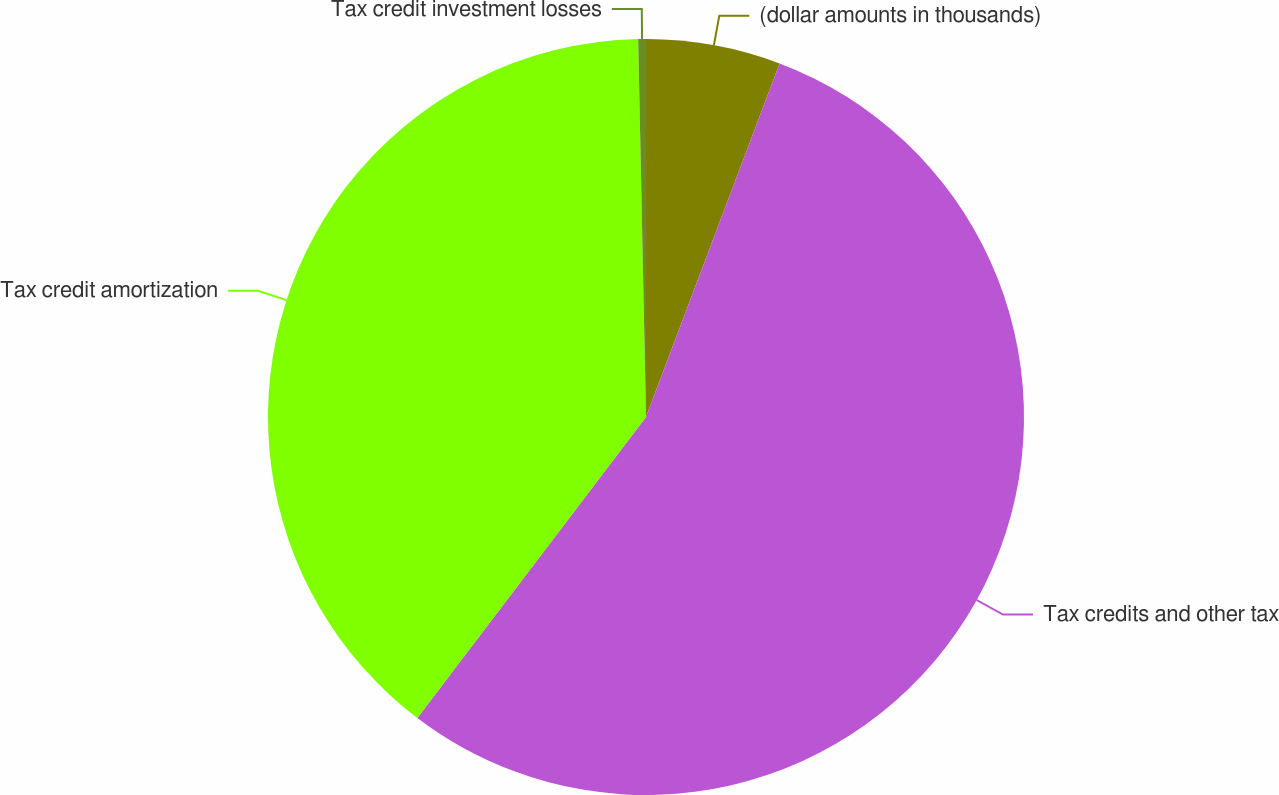<chart> <loc_0><loc_0><loc_500><loc_500><pie_chart><fcel>(dollar amounts in thousands)<fcel>Tax credits and other tax<fcel>Tax credit amortization<fcel>Tax credit investment losses<nl><fcel>5.75%<fcel>54.59%<fcel>39.33%<fcel>0.33%<nl></chart> 